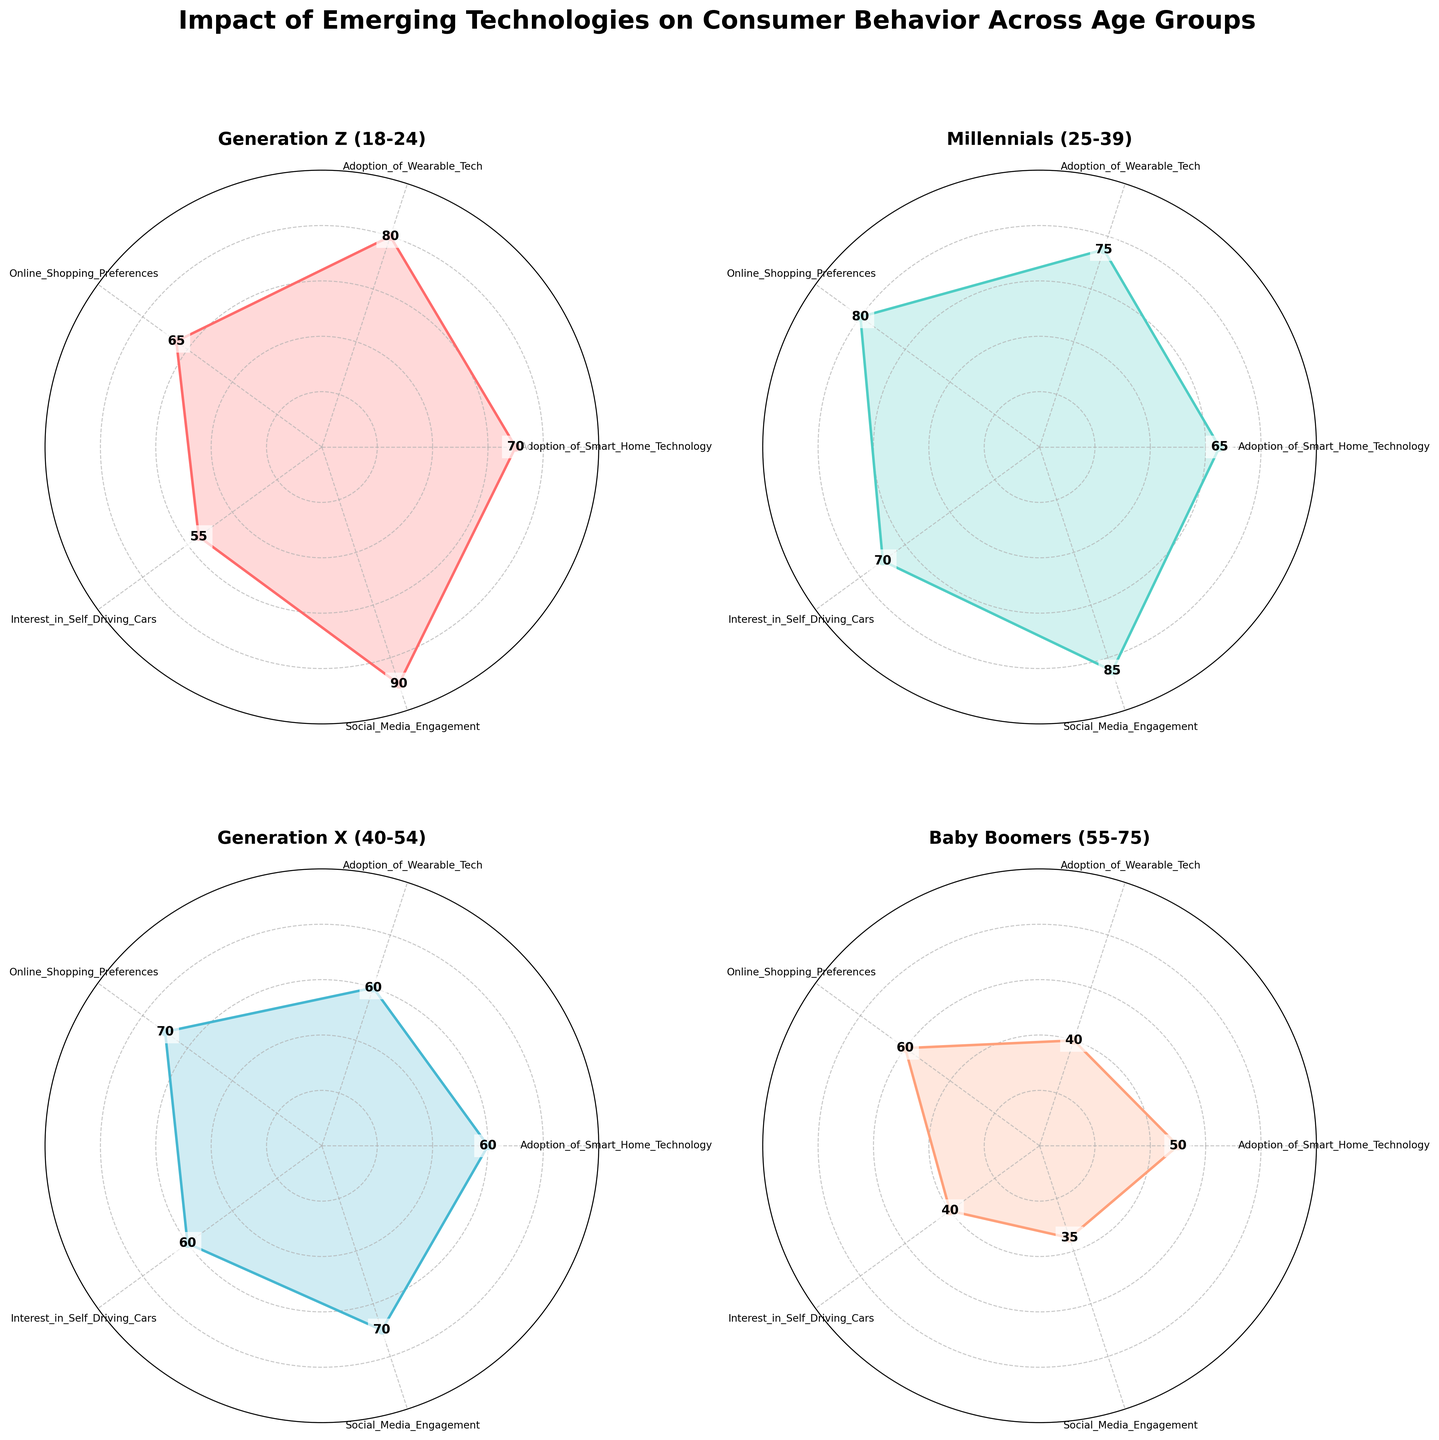What is the title of the figure? The title is usually at the top of the plot and describes the main subject of the figure. Here, it is written in bold and centered.
Answer: Impact of Emerging Technologies on Consumer Behavior Across Age Groups Which age group has the highest engagement in Social Media? We identify the radial axis corresponding to Social Media Engagement and see which age group has the highest value along this axis. Generation Z reaches up to 90 in this category.
Answer: Generation Z (18-24) Compare the adoption of wearable technology between Baby Boomers and Millennials. Which group shows a higher adoption rate? Check the radial axis for Adoption of Wearable Tech for both groups' radar charts. Millennials have a value of 75, while Baby Boomers have 40.
Answer: Millennials (25-39) Among the four age groups, which one has the least interest in self-driving cars? Look at the Interest in Self-Driving Cars radial axis and compare the values. Baby Boomers show the lowest interest with a value of 40.
Answer: Baby Boomers (55-75) What is the average adoption rate of Smart Home Technology across all age groups? Sum the values for Adoption of Smart Home Technology across all age groups (70 + 65 + 60 + 50) and divide by the number of age groups, which is 4. (70+65+60+50)/4 = 61.25
Answer: 61.25 Which age group prefers online shopping the most? Check the radial axis for Online Shopping Preferences and determine which age group has the highest value. Millennials have the highest value at 80.
Answer: Millennials (25-39) Between Generation X and Baby Boomers, which age group shows greater social media engagement? Compare the values on the Social Media Engagement radial axis between Generation X and Baby Boomers. Generation X has a value of 70 while Baby Boomers have 35.
Answer: Generation X (40-54) What is the difference in adoption of Smart Home Technology between Generation Z and Generation X? Identify the respective values for both age groups on the Smart Home Technology radial axis, and subtract Generation X's value from Generation Z's value: 70 - 60 = 10
Answer: 10 If a consumer is likely to be interested in both self-driving cars and wearable tech, which age group would they most likely belong to? Find the age group with high values in both Interest in Self-Driving Cars and Adoption of Wearable Tech. Millennials have high values of 70 and 75, respectively.
Answer: Millennials (25-39) Which category has the most spread in values among all age groups? Evaluate which category has the largest range between the highest and lowest values. Social Media Engagement has the highest (90) and lowest (35) values, giving a spread of 55.
Answer: Social Media Engagement 